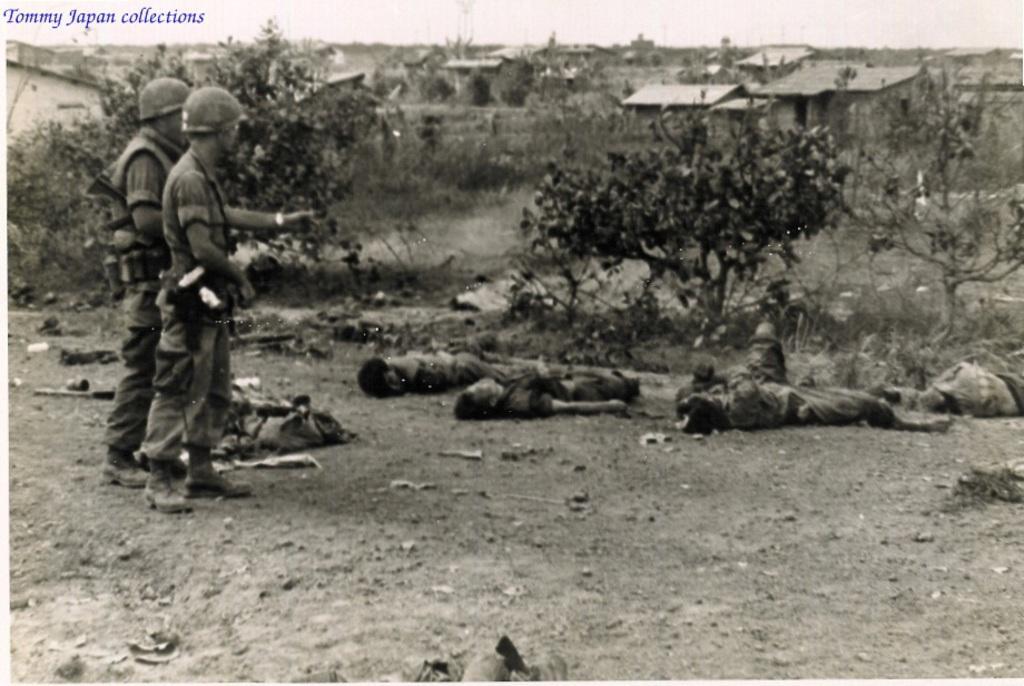Describe this image in one or two sentences. In the picture I can see two men standing on the ground and there is a hard hat on their heads. I can see few people on the ground. In the background, I can see houses and trees. 